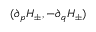<formula> <loc_0><loc_0><loc_500><loc_500>( \partial _ { p } H _ { \pm } , - \partial _ { q } H _ { \pm } )</formula> 